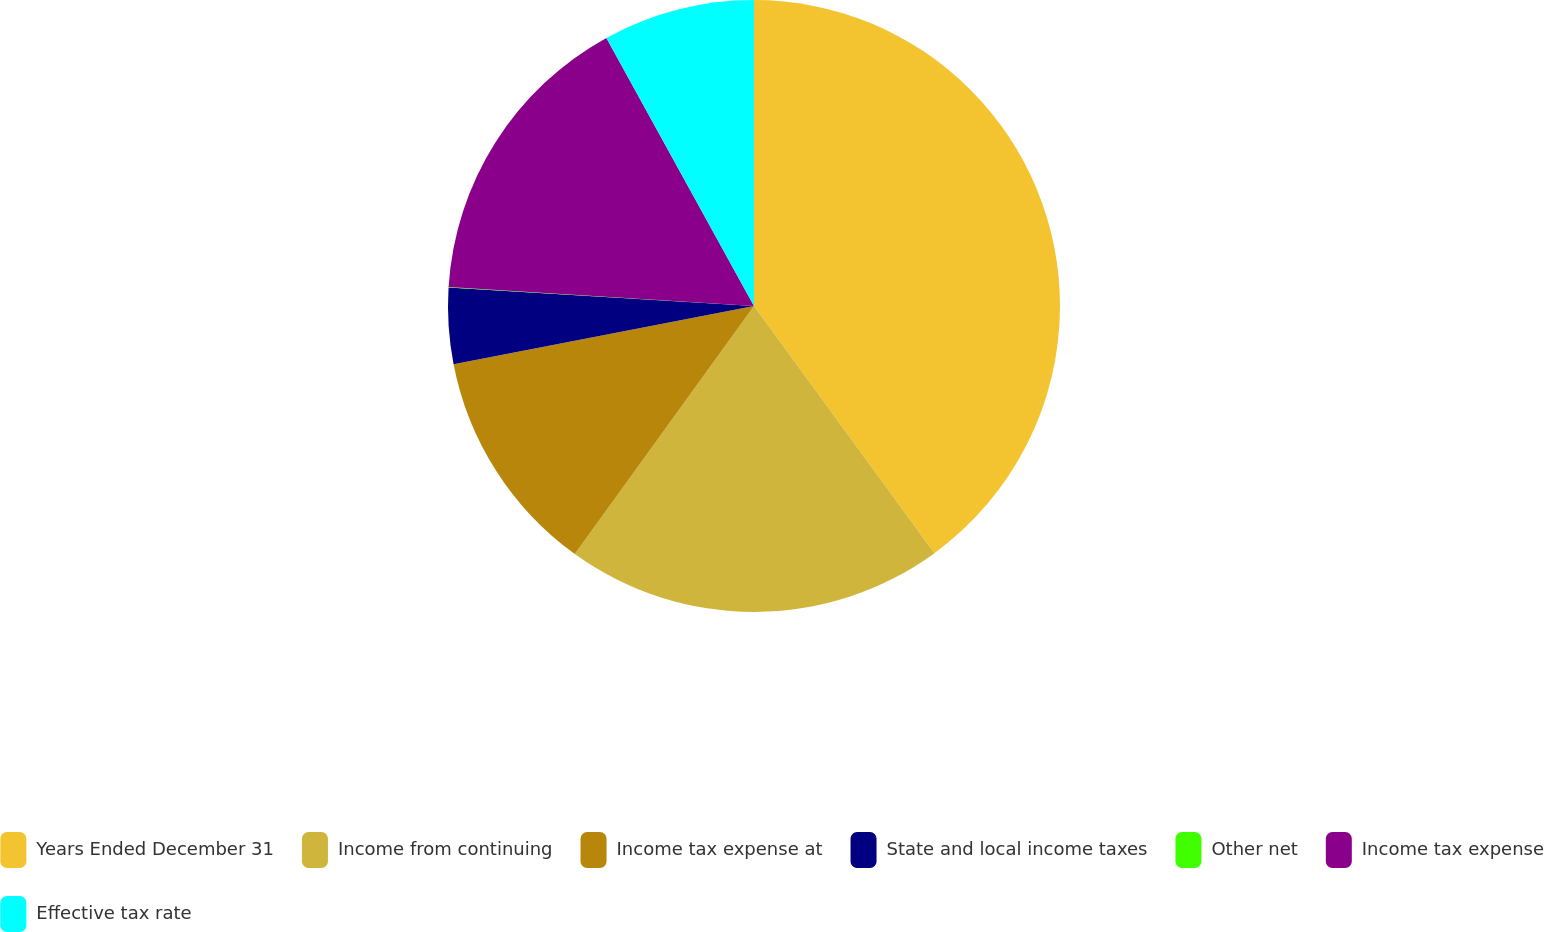Convert chart. <chart><loc_0><loc_0><loc_500><loc_500><pie_chart><fcel>Years Ended December 31<fcel>Income from continuing<fcel>Income tax expense at<fcel>State and local income taxes<fcel>Other net<fcel>Income tax expense<fcel>Effective tax rate<nl><fcel>39.96%<fcel>19.99%<fcel>12.0%<fcel>4.01%<fcel>0.02%<fcel>16.0%<fcel>8.01%<nl></chart> 